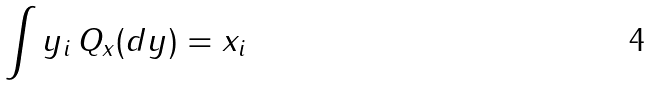<formula> <loc_0><loc_0><loc_500><loc_500>\int y _ { i } \, Q _ { x } ( d y ) = x _ { i }</formula> 